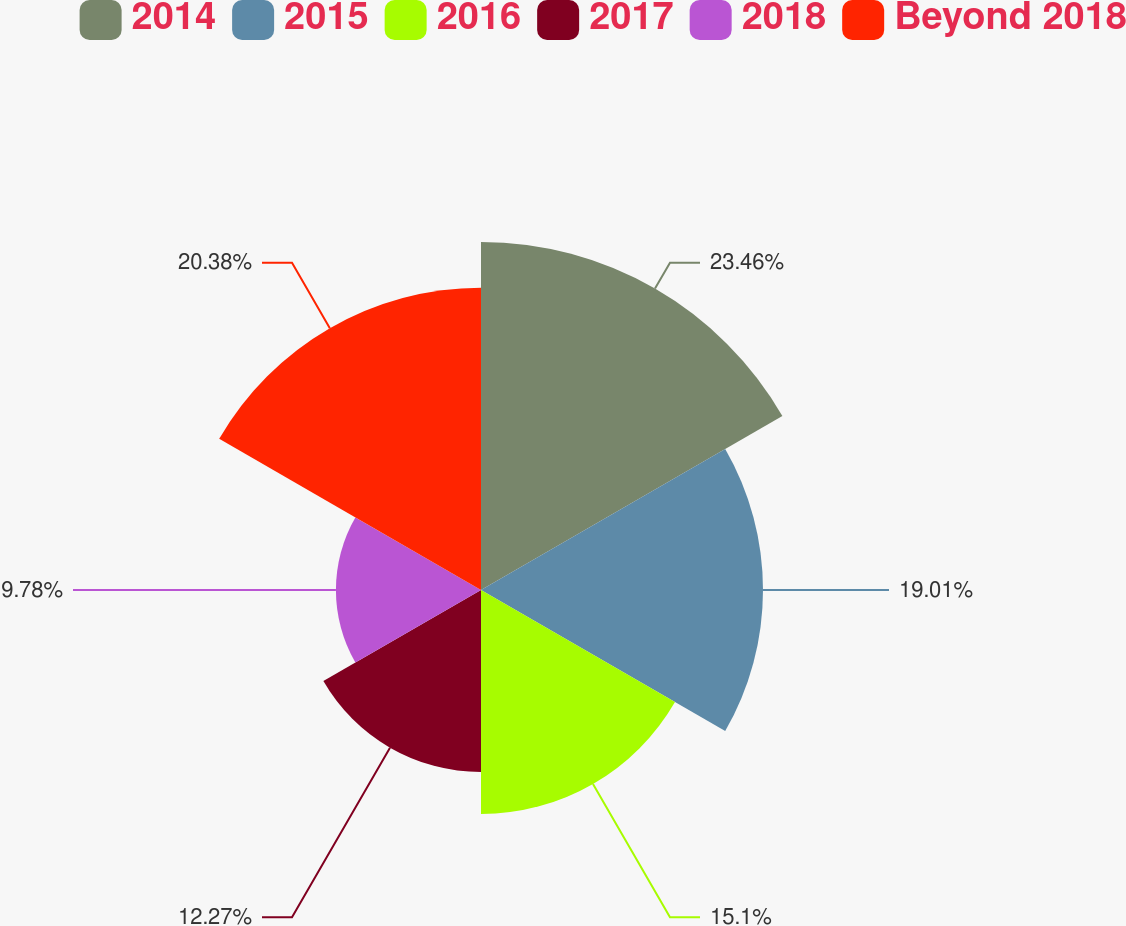Convert chart. <chart><loc_0><loc_0><loc_500><loc_500><pie_chart><fcel>2014<fcel>2015<fcel>2016<fcel>2017<fcel>2018<fcel>Beyond 2018<nl><fcel>23.46%<fcel>19.01%<fcel>15.1%<fcel>12.27%<fcel>9.78%<fcel>20.38%<nl></chart> 